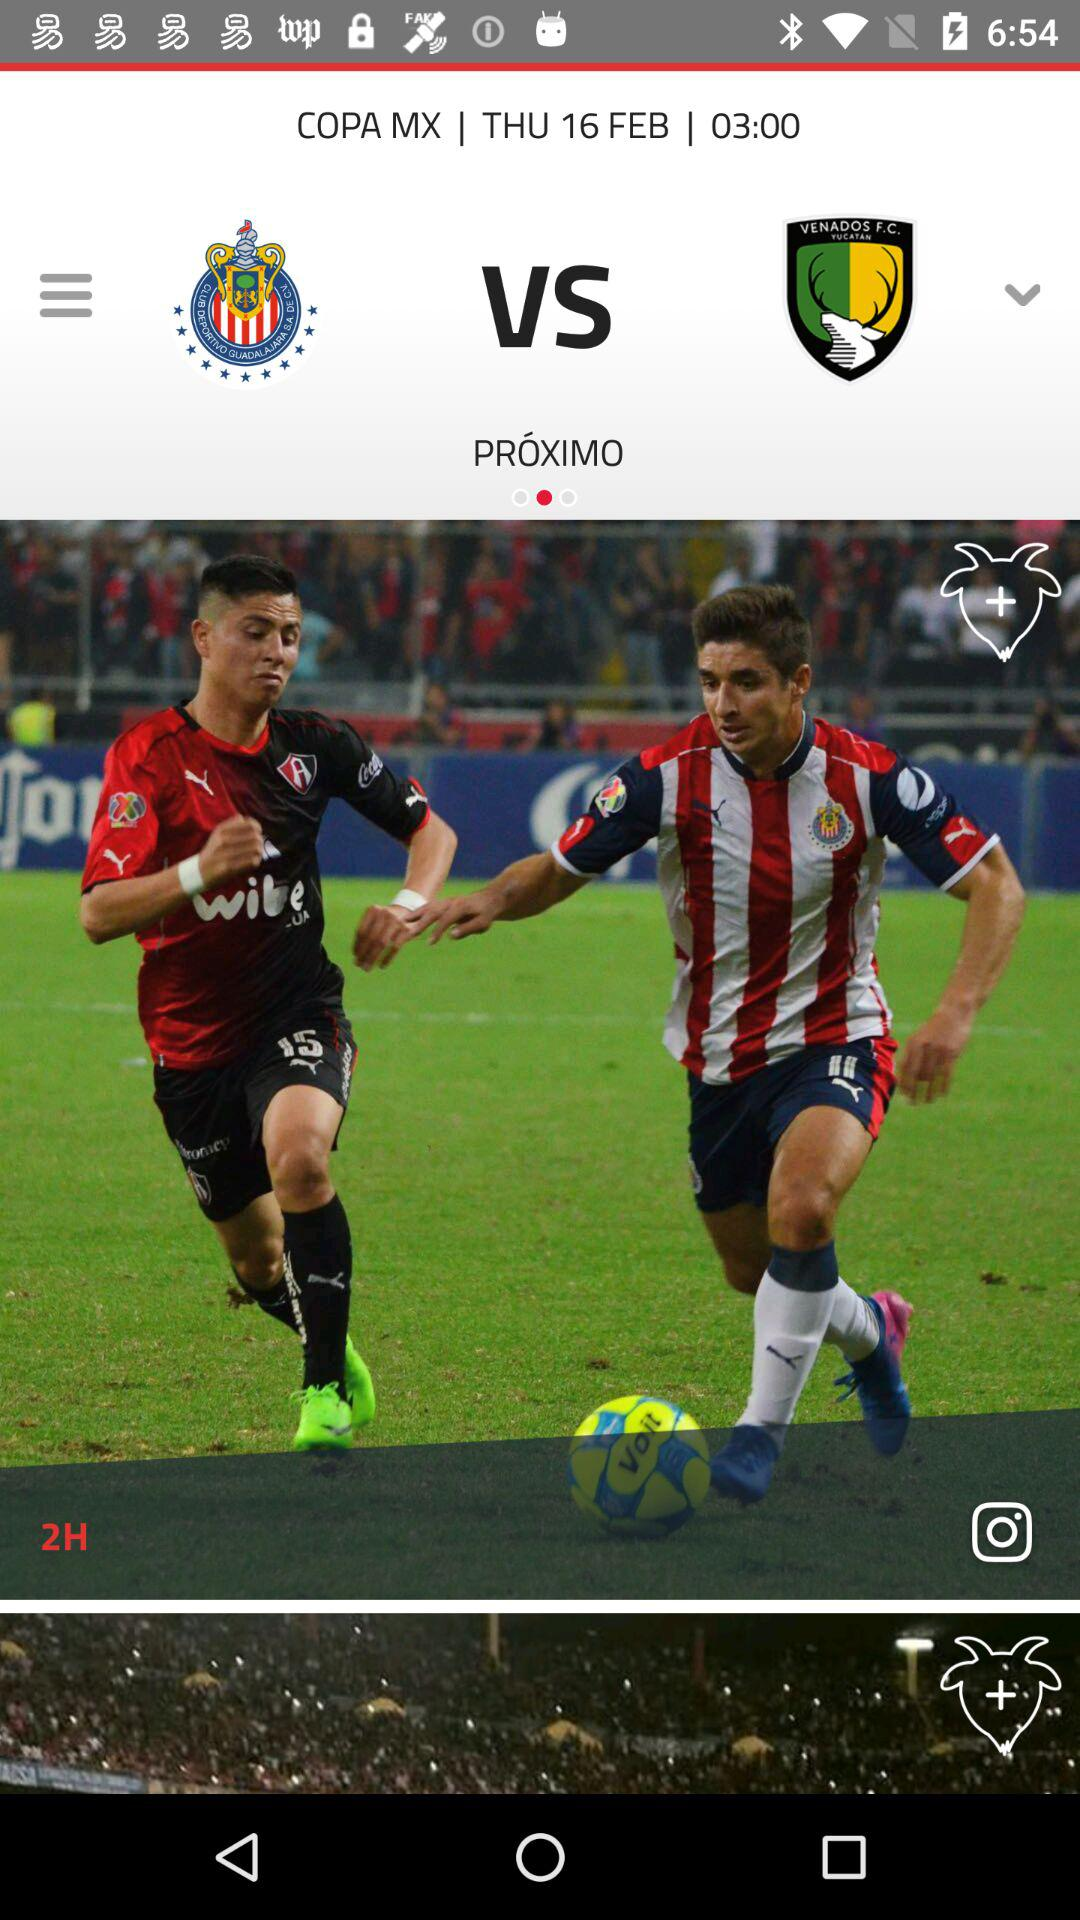What kind of event is being portrayed in the image? The image depicts a scene from a soccer match between two teams, as evidenced by the players in athletic attire competing for the ball on the pitch. What time is the game scheduled to start? The game is scheduled to start at 03:00, as shown in the details above the image which include the match information. 